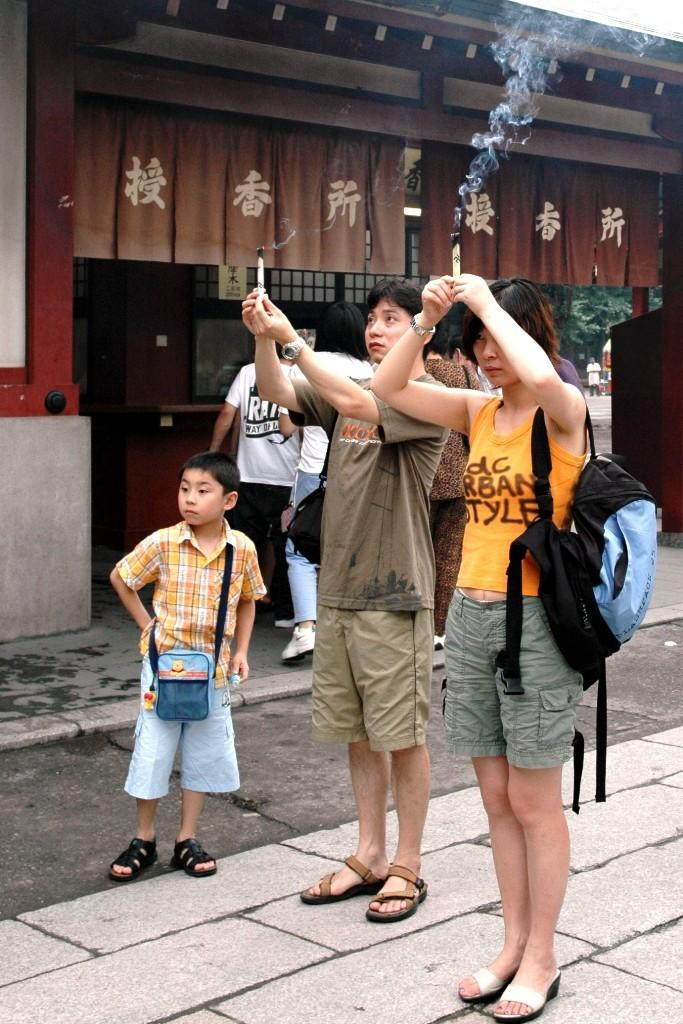How many people are in the image? There are two persons in the image. What are the persons wearing? The persons are wearing clothes. What are the persons holding in the image? The persons are holding incense sticks. Where is the kid located in the image? The kid is on the left side of the image. What is the kid standing in front of? The kid is standing in front of a building. Can you tell me which flower the kid is holding in the image? There is no flower present in the image; the kid is standing in front of a building and not holding anything. 